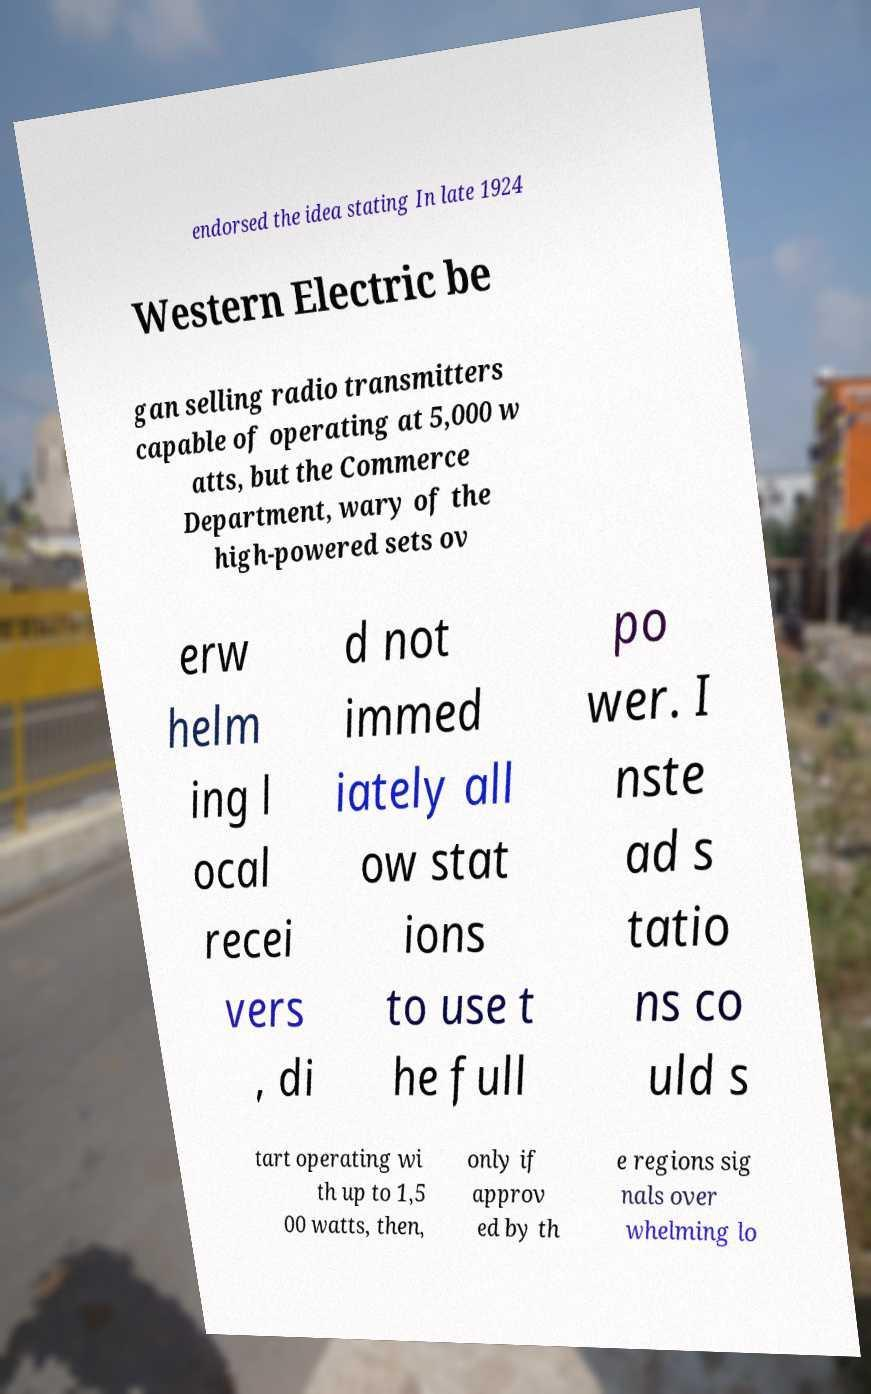For documentation purposes, I need the text within this image transcribed. Could you provide that? endorsed the idea stating In late 1924 Western Electric be gan selling radio transmitters capable of operating at 5,000 w atts, but the Commerce Department, wary of the high-powered sets ov erw helm ing l ocal recei vers , di d not immed iately all ow stat ions to use t he full po wer. I nste ad s tatio ns co uld s tart operating wi th up to 1,5 00 watts, then, only if approv ed by th e regions sig nals over whelming lo 